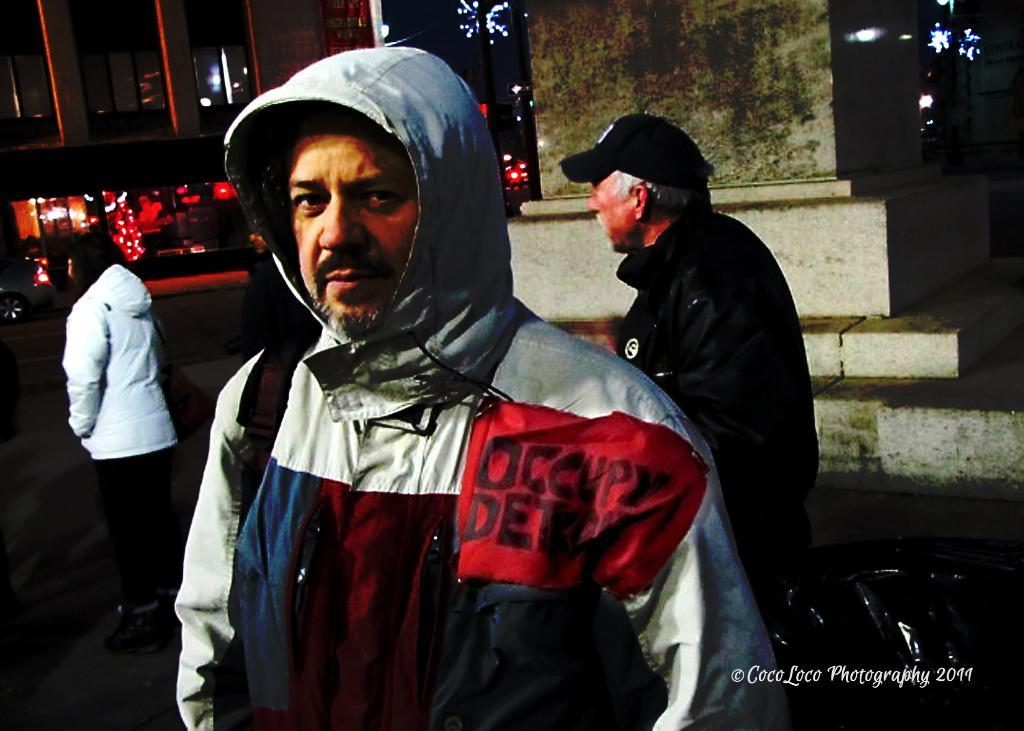What is the man in the image wearing? The man is wearing a hoodie in the image. Can you describe the people behind the man? There are two persons behind the man in the image. What is present in the bottom right side of the image? There is a watermark on the bottom right side of the image. What can be seen in the background of the image? There is a building in the background of the image. What type of beef is being served on the throne in the image? There is no beef or throne present in the image; it features a man wearing a hoodie and other people and objects. 